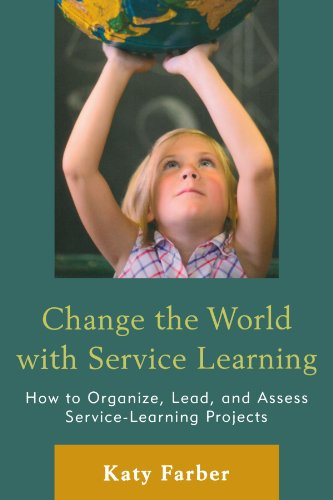Who wrote this book? The author of the book displayed in the image is Katy Farber. She focuses on educational topics, particularly related to service learning and environmental education. 